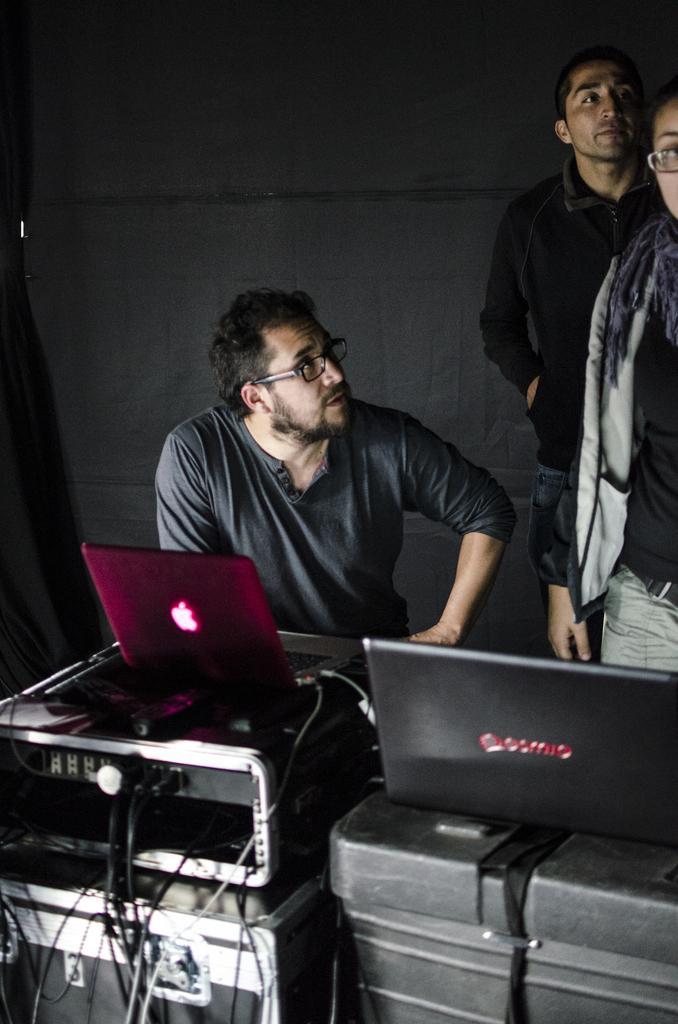In one or two sentences, can you explain what this image depicts? In the picture I can see some people, in front of them we can see some laptops and boxes are placed. 